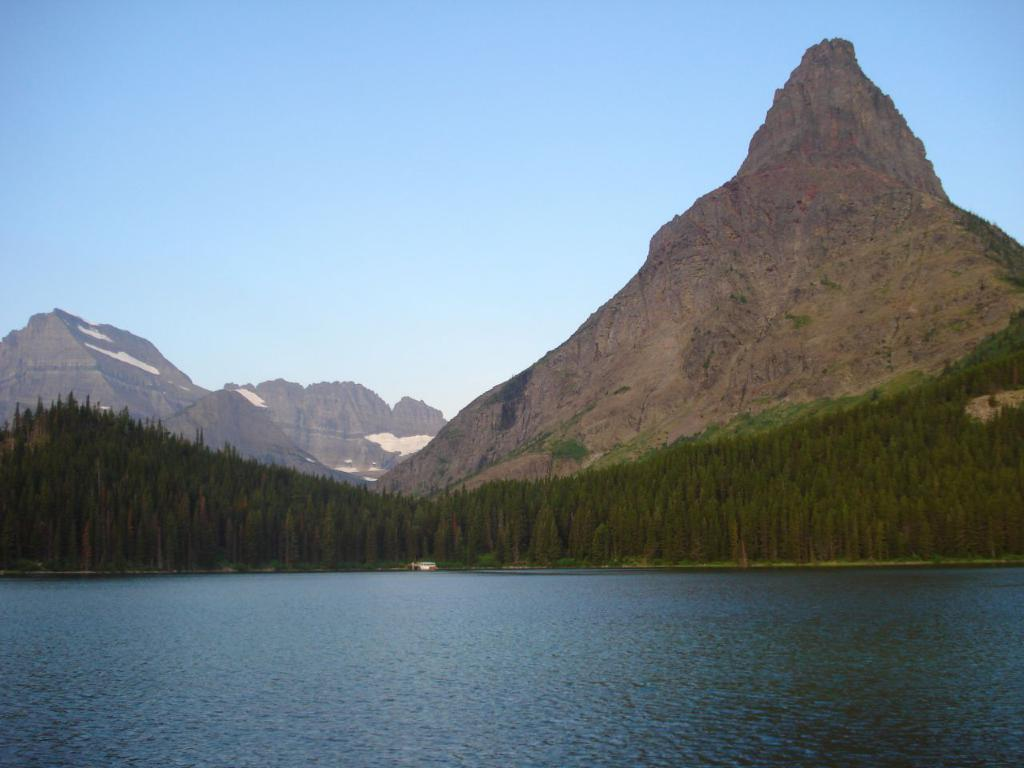What is visible in the image? Water is visible in the image. What can be seen in the background of the image? There are trees and mountains in the background of the image. What is the condition of the sky in the image? The sky is clear in the background of the image. Can you see any ghosts washing their hands in the image? There are no ghosts or hands visible in the image. 